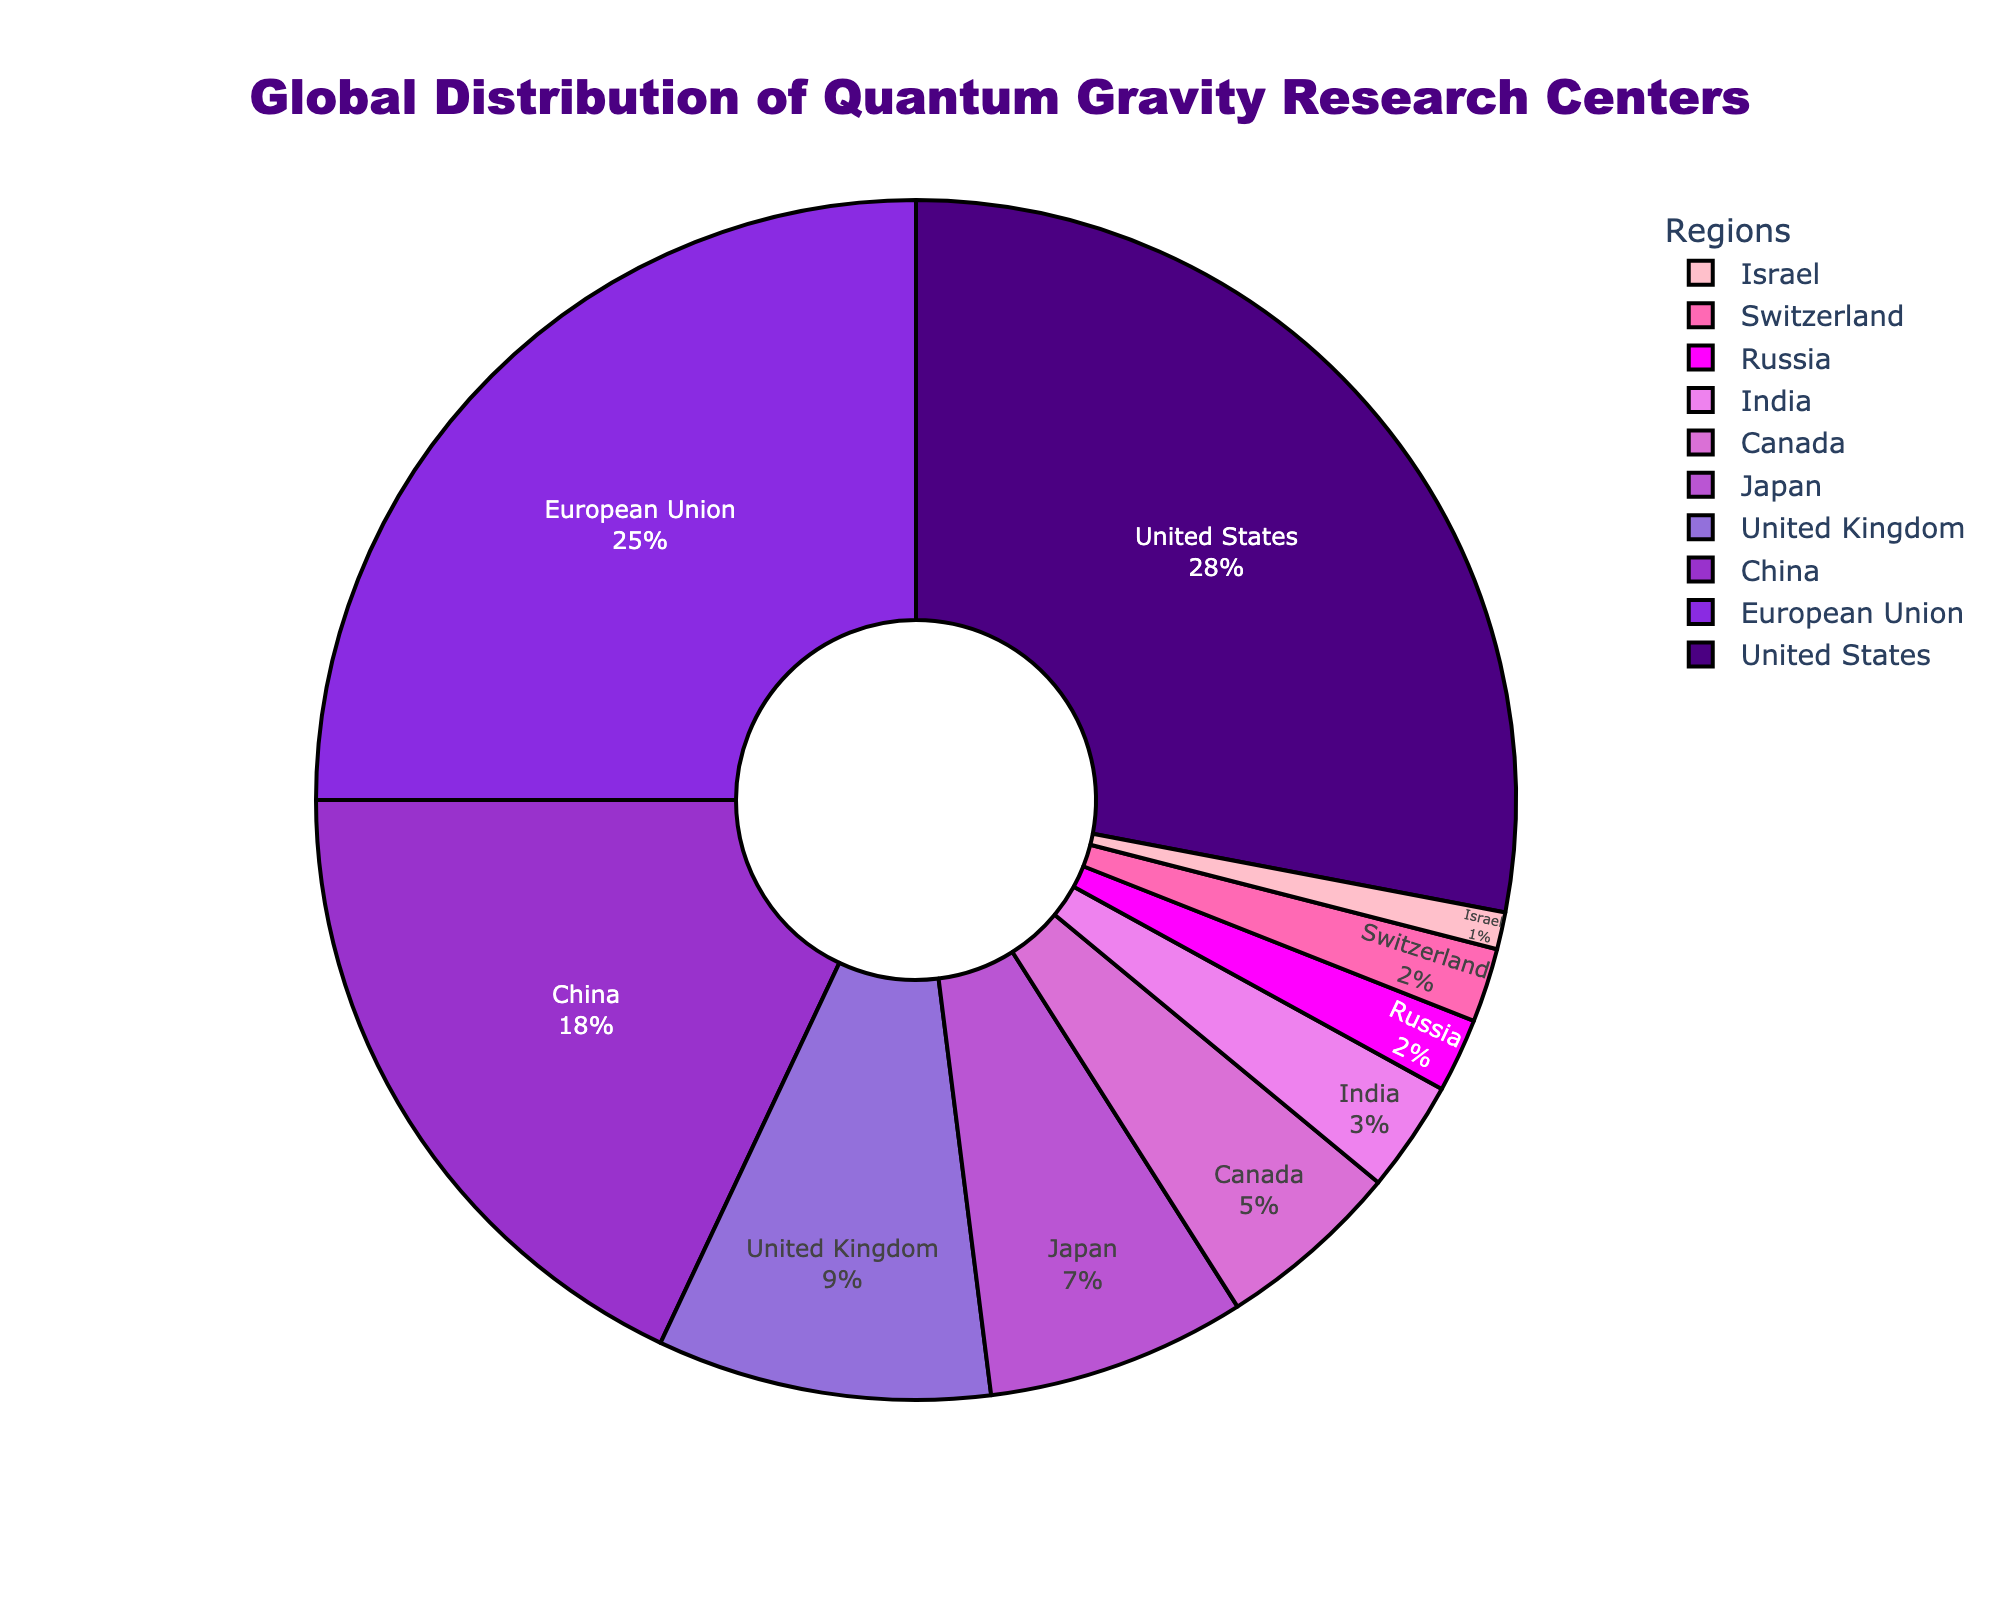Which region has the highest percentage of quantum gravity research centers? The pie chart shows the distribution of percentages. The United States has the largest slice which also has the highest percentage of 28%.
Answer: United States Which regions have less than 5% of the quantum gravity research centers? The chart shows that Canada, India, Russia, Switzerland, and Israel have smaller slices, all of which are less than 5% each.
Answer: Canada, India, Russia, Switzerland, Israel What is the combined percentage of quantum gravity research centers in the US, EU, and China? The percentages for the US, EU, and China are 28%, 25%, and 18% respectively. Adding these values gives 28 + 25 + 18 = 71%.
Answer: 71% Which region has the smallest percentage of quantum gravity research centers? The chart shows that Israel has the smallest slice of the pie, indicating the lowest percentage of 1%.
Answer: Israel What is the difference in percentage between the United States and the European Union for quantum gravity research centers? The United States has 28% and the European Union has 25%. The difference is calculated as 28 - 25 = 3%.
Answer: 3% Do Japan and the United Kingdom together have a higher percentage of research centers than China? Japan has 7% and the United Kingdom has 9%. Summing these gives 7 + 9 = 16%, which is less than China's 18%.
Answer: No Which two regions combined have a percentage roughly equal to the United States? The United States has 28%. The EU (25%) and Canada (5%) together have 25 + 5 = 30%, which is the closest sum to 28%.
Answer: European Union and Canada What percentage of research centers are located outside of the United States? The total percentage is 100%. Subtracting the United States' 28% gives 100 - 28 = 72%.
Answer: 72% Which color in the pie chart represents the region with 7% representation? The visual attribute shows that the purple color represents Japan, which has 7% of the research centers.
Answer: Purple What is the sum of the percentages of research centers in countries with less than 10% representation each? Summing all percentages under 10%: United Kingdom (9%) + Japan (7%) + Canada (5%) + India (3%) + Russia (2%) + Switzerland (2%) + Israel (1%) gives 9 + 7 + 5 + 3 + 2 + 2 + 1 = 29%.
Answer: 29% 